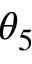<formula> <loc_0><loc_0><loc_500><loc_500>\theta _ { 5 }</formula> 